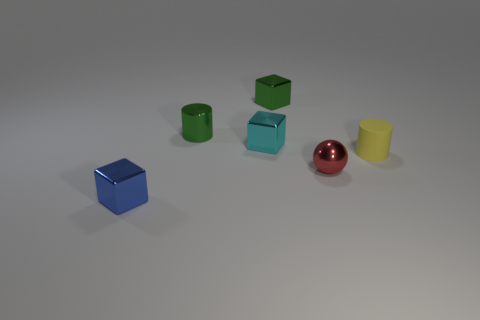Subtract all yellow balls. Subtract all gray blocks. How many balls are left? 1 Add 1 green matte balls. How many objects exist? 7 Subtract all cylinders. How many objects are left? 4 Subtract all matte balls. Subtract all metallic spheres. How many objects are left? 5 Add 5 cyan objects. How many cyan objects are left? 6 Add 6 tiny cyan blocks. How many tiny cyan blocks exist? 7 Subtract 1 red spheres. How many objects are left? 5 